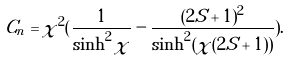Convert formula to latex. <formula><loc_0><loc_0><loc_500><loc_500>C _ { n } = \chi ^ { 2 } ( \frac { 1 } { \sinh ^ { 2 } \chi } - \frac { ( 2 S + 1 ) ^ { 2 } } { \sinh ^ { 2 } ( \chi ( 2 S + 1 ) ) } ) .</formula> 